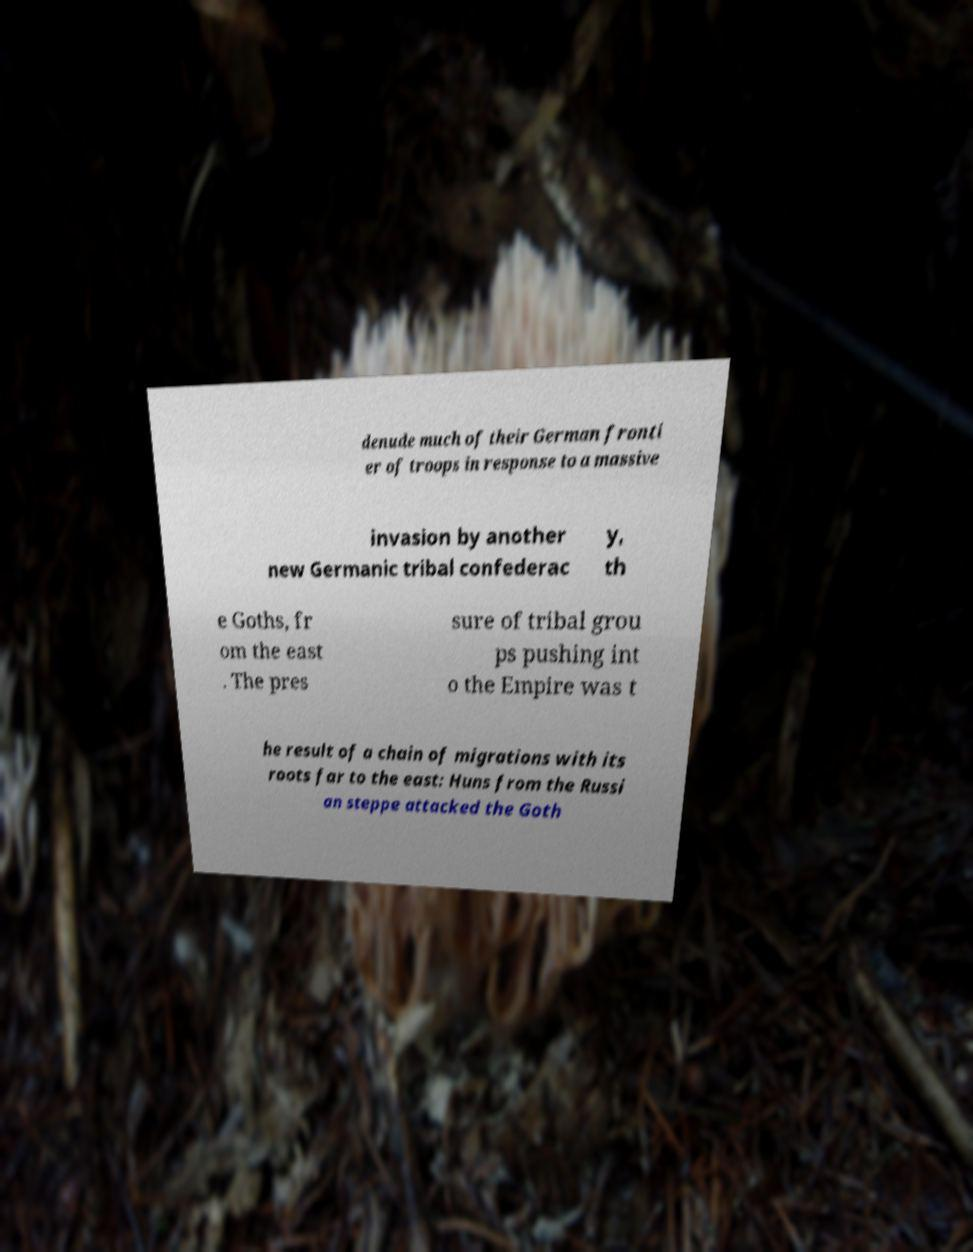What messages or text are displayed in this image? I need them in a readable, typed format. denude much of their German fronti er of troops in response to a massive invasion by another new Germanic tribal confederac y, th e Goths, fr om the east . The pres sure of tribal grou ps pushing int o the Empire was t he result of a chain of migrations with its roots far to the east: Huns from the Russi an steppe attacked the Goth 